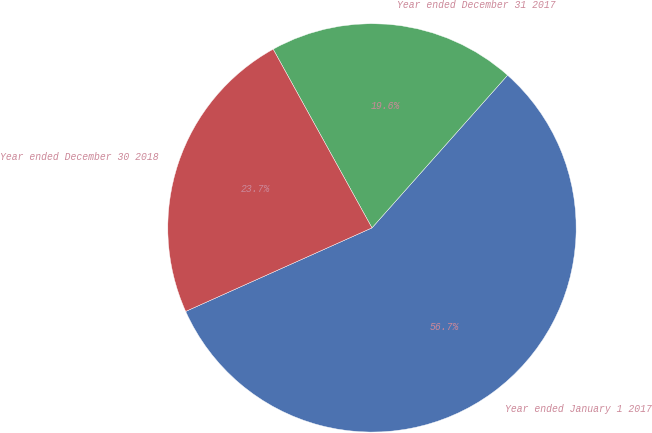<chart> <loc_0><loc_0><loc_500><loc_500><pie_chart><fcel>Year ended January 1 2017<fcel>Year ended December 31 2017<fcel>Year ended December 30 2018<nl><fcel>56.73%<fcel>19.6%<fcel>23.67%<nl></chart> 